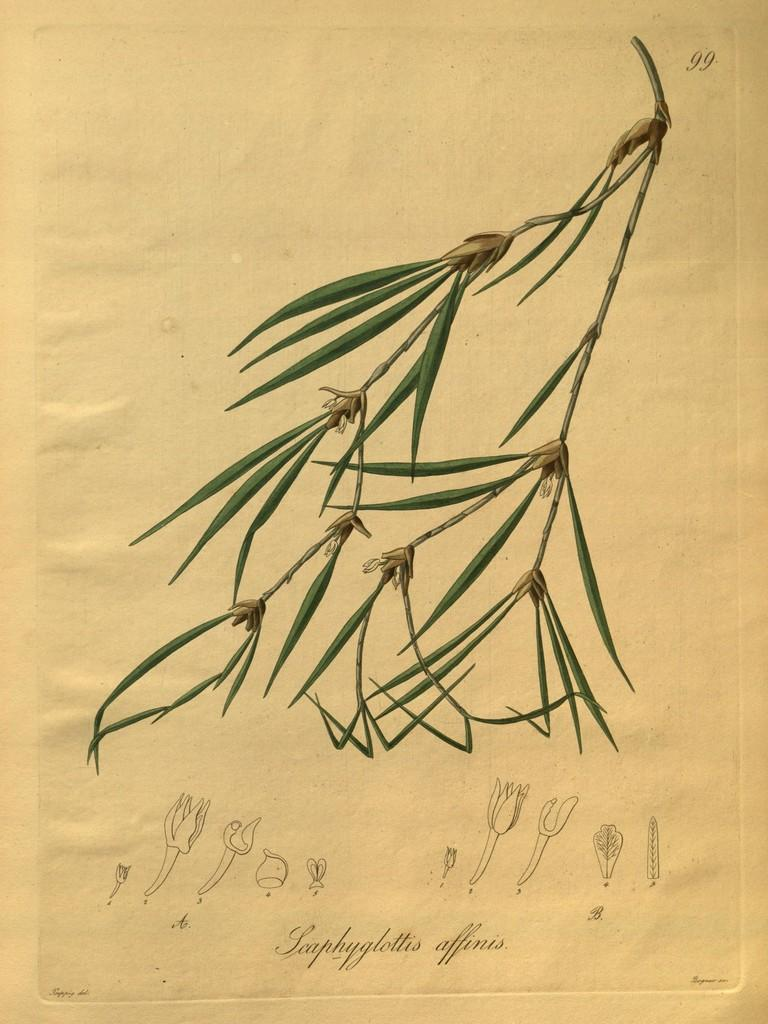What is present on the paper in the image? The paper contains a drawing of grass and some text. Can you describe the drawing on the paper? The drawing on the paper is of grass. What else can be found on the paper besides the drawing? There is text on the paper. How many mice are jumping on the grass in the drawing? There are no mice present in the image, and the drawing is of grass only, not mice. 